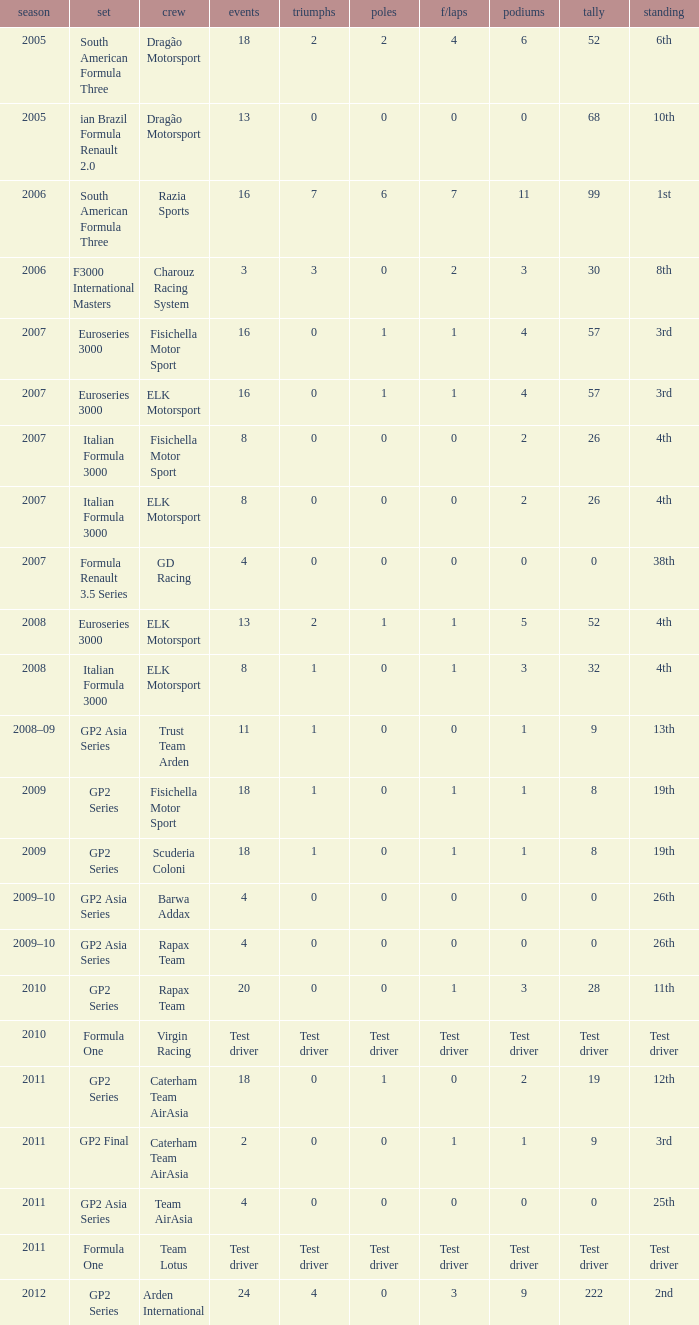What was his position in 2009 with 1 win? 19th, 19th. 